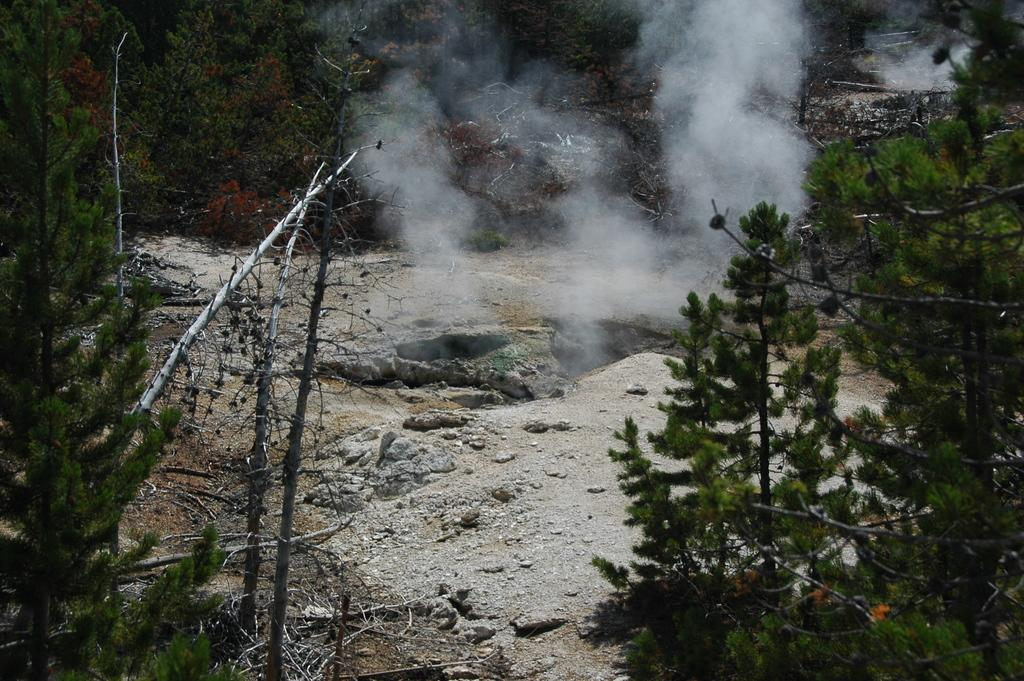What type of natural elements can be seen in the image? There are rocks in the image. What other natural elements are present in the image? There are trees around the rocks in the image. What type of clover can be seen growing near the rocks in the image? There is no clover present in the image; only rocks and trees are visible. What month is it in the image? The month cannot be determined from the image, as there are no seasonal or time-specific clues present. 